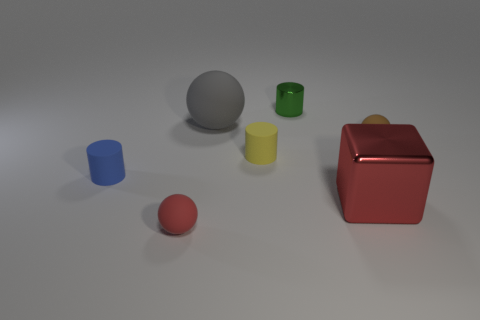Is the material of the tiny ball that is behind the yellow cylinder the same as the tiny red thing?
Provide a short and direct response. Yes. Is the number of red metal things in front of the large red shiny thing the same as the number of small brown matte objects that are behind the small green metallic object?
Provide a short and direct response. Yes. There is a matte cylinder that is right of the small matte object that is left of the red rubber ball; what size is it?
Offer a terse response. Small. The ball that is both left of the small brown sphere and behind the red metallic object is made of what material?
Your answer should be very brief. Rubber. How many other objects are the same size as the gray thing?
Give a very brief answer. 1. The block has what color?
Your answer should be very brief. Red. There is a tiny rubber ball in front of the small blue object; does it have the same color as the large thing that is to the left of the small yellow matte cylinder?
Provide a succinct answer. No. How big is the green metallic cylinder?
Offer a very short reply. Small. What is the size of the red thing behind the red matte thing?
Your answer should be very brief. Large. What shape is the object that is behind the yellow cylinder and in front of the big matte ball?
Ensure brevity in your answer.  Sphere. 